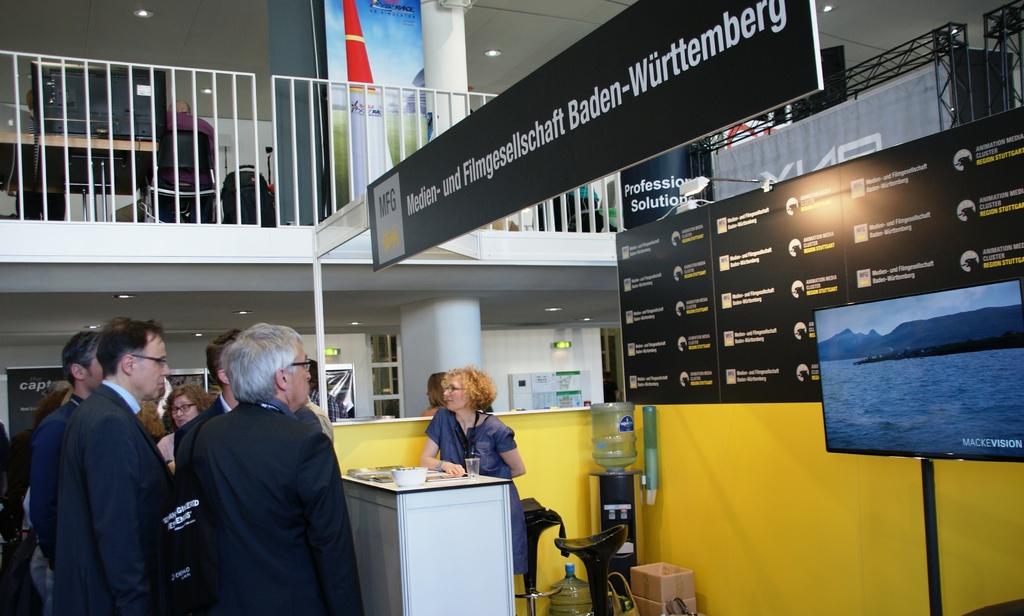What does the black sign say?
Give a very brief answer. Medien-und filmgesellschaft baden-wurttemberg. What type of solutions?
Offer a very short reply. Professional. 